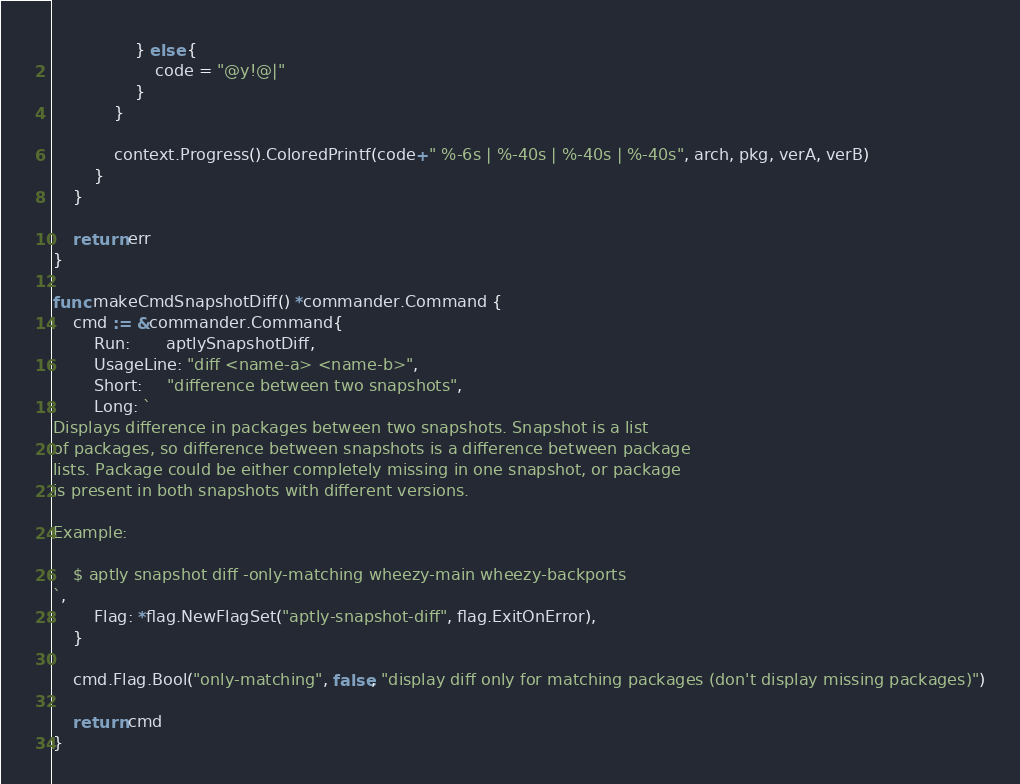<code> <loc_0><loc_0><loc_500><loc_500><_Go_>				} else {
					code = "@y!@|"
				}
			}

			context.Progress().ColoredPrintf(code+" %-6s | %-40s | %-40s | %-40s", arch, pkg, verA, verB)
		}
	}

	return err
}

func makeCmdSnapshotDiff() *commander.Command {
	cmd := &commander.Command{
		Run:       aptlySnapshotDiff,
		UsageLine: "diff <name-a> <name-b>",
		Short:     "difference between two snapshots",
		Long: `
Displays difference in packages between two snapshots. Snapshot is a list
of packages, so difference between snapshots is a difference between package
lists. Package could be either completely missing in one snapshot, or package
is present in both snapshots with different versions.

Example:

    $ aptly snapshot diff -only-matching wheezy-main wheezy-backports
`,
		Flag: *flag.NewFlagSet("aptly-snapshot-diff", flag.ExitOnError),
	}

	cmd.Flag.Bool("only-matching", false, "display diff only for matching packages (don't display missing packages)")

	return cmd
}
</code> 